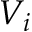<formula> <loc_0><loc_0><loc_500><loc_500>V _ { i }</formula> 